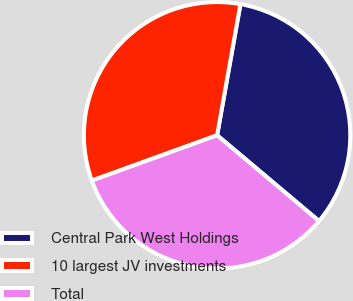Convert chart. <chart><loc_0><loc_0><loc_500><loc_500><pie_chart><fcel>Central Park West Holdings<fcel>10 largest JV investments<fcel>Total<nl><fcel>33.33%<fcel>33.33%<fcel>33.33%<nl></chart> 